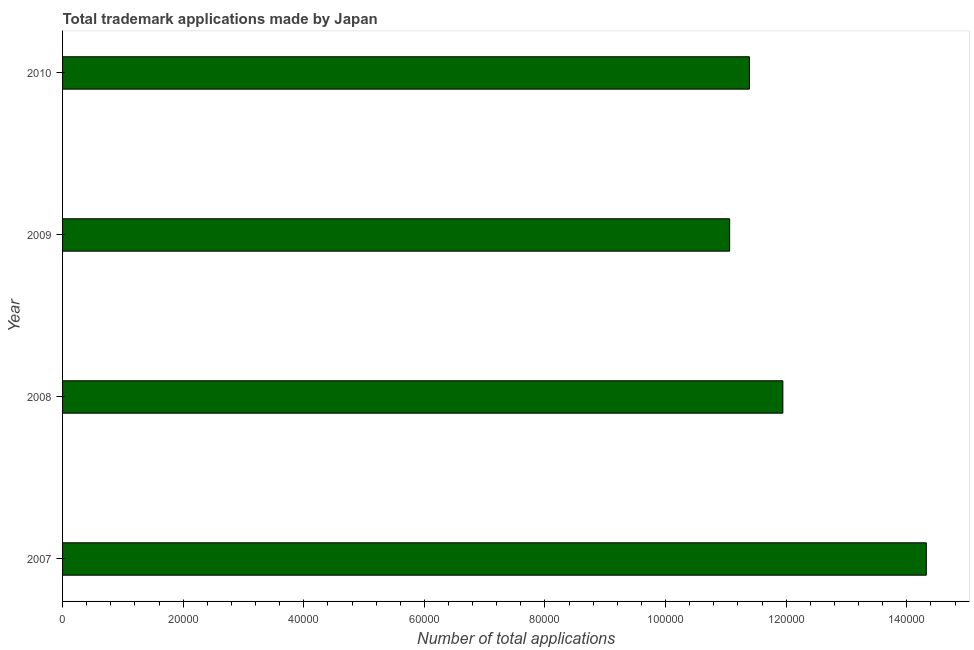Does the graph contain any zero values?
Give a very brief answer. No. Does the graph contain grids?
Your answer should be very brief. No. What is the title of the graph?
Give a very brief answer. Total trademark applications made by Japan. What is the label or title of the X-axis?
Provide a succinct answer. Number of total applications. What is the number of trademark applications in 2008?
Your answer should be very brief. 1.19e+05. Across all years, what is the maximum number of trademark applications?
Your response must be concise. 1.43e+05. Across all years, what is the minimum number of trademark applications?
Give a very brief answer. 1.11e+05. In which year was the number of trademark applications minimum?
Your answer should be compact. 2009. What is the sum of the number of trademark applications?
Your answer should be compact. 4.87e+05. What is the difference between the number of trademark applications in 2008 and 2009?
Your answer should be compact. 8826. What is the average number of trademark applications per year?
Give a very brief answer. 1.22e+05. What is the median number of trademark applications?
Provide a short and direct response. 1.17e+05. What is the ratio of the number of trademark applications in 2007 to that in 2009?
Keep it short and to the point. 1.29. Is the number of trademark applications in 2007 less than that in 2008?
Offer a terse response. No. Is the difference between the number of trademark applications in 2007 and 2010 greater than the difference between any two years?
Ensure brevity in your answer.  No. What is the difference between the highest and the second highest number of trademark applications?
Offer a very short reply. 2.38e+04. Is the sum of the number of trademark applications in 2008 and 2009 greater than the maximum number of trademark applications across all years?
Provide a short and direct response. Yes. What is the difference between the highest and the lowest number of trademark applications?
Keep it short and to the point. 3.26e+04. How many years are there in the graph?
Provide a short and direct response. 4. What is the difference between two consecutive major ticks on the X-axis?
Offer a very short reply. 2.00e+04. What is the Number of total applications in 2007?
Offer a very short reply. 1.43e+05. What is the Number of total applications of 2008?
Make the answer very short. 1.19e+05. What is the Number of total applications in 2009?
Your answer should be compact. 1.11e+05. What is the Number of total applications of 2010?
Give a very brief answer. 1.14e+05. What is the difference between the Number of total applications in 2007 and 2008?
Give a very brief answer. 2.38e+04. What is the difference between the Number of total applications in 2007 and 2009?
Your response must be concise. 3.26e+04. What is the difference between the Number of total applications in 2007 and 2010?
Provide a short and direct response. 2.93e+04. What is the difference between the Number of total applications in 2008 and 2009?
Offer a terse response. 8826. What is the difference between the Number of total applications in 2008 and 2010?
Keep it short and to the point. 5546. What is the difference between the Number of total applications in 2009 and 2010?
Provide a succinct answer. -3280. What is the ratio of the Number of total applications in 2007 to that in 2008?
Make the answer very short. 1.2. What is the ratio of the Number of total applications in 2007 to that in 2009?
Offer a terse response. 1.29. What is the ratio of the Number of total applications in 2007 to that in 2010?
Provide a short and direct response. 1.26. What is the ratio of the Number of total applications in 2008 to that in 2010?
Offer a very short reply. 1.05. What is the ratio of the Number of total applications in 2009 to that in 2010?
Provide a short and direct response. 0.97. 